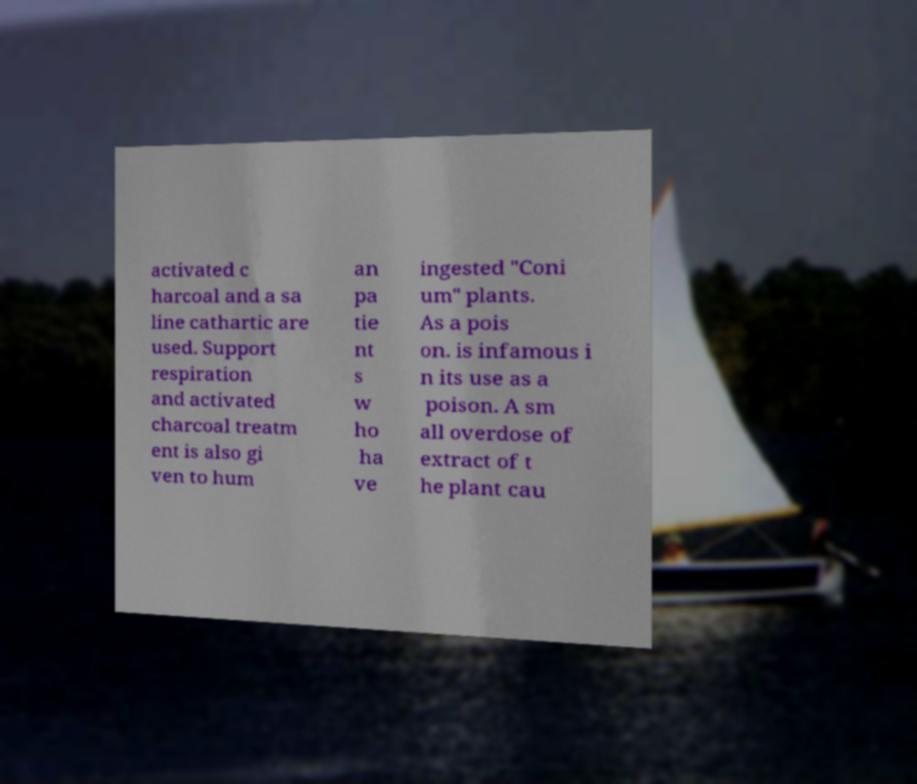Can you accurately transcribe the text from the provided image for me? activated c harcoal and a sa line cathartic are used. Support respiration and activated charcoal treatm ent is also gi ven to hum an pa tie nt s w ho ha ve ingested "Coni um" plants. As a pois on. is infamous i n its use as a poison. A sm all overdose of extract of t he plant cau 